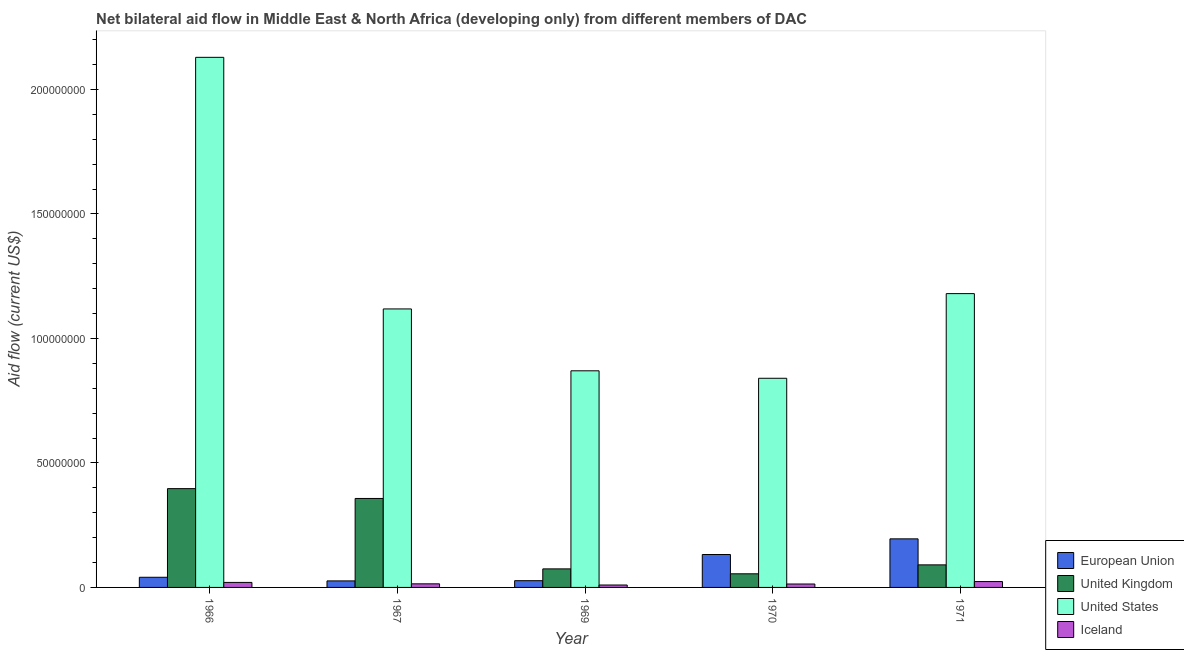How many different coloured bars are there?
Provide a short and direct response. 4. Are the number of bars per tick equal to the number of legend labels?
Keep it short and to the point. Yes. Are the number of bars on each tick of the X-axis equal?
Provide a short and direct response. Yes. How many bars are there on the 5th tick from the left?
Offer a very short reply. 4. How many bars are there on the 5th tick from the right?
Offer a very short reply. 4. What is the label of the 1st group of bars from the left?
Keep it short and to the point. 1966. What is the amount of aid given by iceland in 1969?
Offer a terse response. 9.70e+05. Across all years, what is the maximum amount of aid given by us?
Make the answer very short. 2.13e+08. Across all years, what is the minimum amount of aid given by iceland?
Offer a very short reply. 9.70e+05. In which year was the amount of aid given by us maximum?
Provide a short and direct response. 1966. In which year was the amount of aid given by iceland minimum?
Offer a very short reply. 1969. What is the total amount of aid given by iceland in the graph?
Provide a succinct answer. 8.15e+06. What is the difference between the amount of aid given by iceland in 1969 and that in 1971?
Ensure brevity in your answer.  -1.39e+06. What is the difference between the amount of aid given by uk in 1971 and the amount of aid given by eu in 1969?
Ensure brevity in your answer.  1.61e+06. What is the average amount of aid given by uk per year?
Your answer should be very brief. 1.95e+07. In how many years, is the amount of aid given by iceland greater than 100000000 US$?
Make the answer very short. 0. What is the ratio of the amount of aid given by eu in 1967 to that in 1969?
Make the answer very short. 0.97. Is the amount of aid given by us in 1966 less than that in 1970?
Give a very brief answer. No. Is the difference between the amount of aid given by us in 1969 and 1971 greater than the difference between the amount of aid given by iceland in 1969 and 1971?
Keep it short and to the point. No. What is the difference between the highest and the second highest amount of aid given by eu?
Your answer should be very brief. 6.29e+06. What is the difference between the highest and the lowest amount of aid given by eu?
Keep it short and to the point. 1.69e+07. What does the 3rd bar from the left in 1966 represents?
Offer a terse response. United States. How many bars are there?
Offer a very short reply. 20. Are the values on the major ticks of Y-axis written in scientific E-notation?
Make the answer very short. No. Does the graph contain grids?
Keep it short and to the point. No. What is the title of the graph?
Offer a very short reply. Net bilateral aid flow in Middle East & North Africa (developing only) from different members of DAC. Does "Gender equality" appear as one of the legend labels in the graph?
Keep it short and to the point. No. What is the Aid flow (current US$) of European Union in 1966?
Your response must be concise. 4.08e+06. What is the Aid flow (current US$) in United Kingdom in 1966?
Provide a succinct answer. 3.97e+07. What is the Aid flow (current US$) of United States in 1966?
Give a very brief answer. 2.13e+08. What is the Aid flow (current US$) of Iceland in 1966?
Offer a very short reply. 2.01e+06. What is the Aid flow (current US$) in European Union in 1967?
Ensure brevity in your answer.  2.62e+06. What is the Aid flow (current US$) in United Kingdom in 1967?
Keep it short and to the point. 3.57e+07. What is the Aid flow (current US$) of United States in 1967?
Provide a succinct answer. 1.12e+08. What is the Aid flow (current US$) in Iceland in 1967?
Provide a short and direct response. 1.44e+06. What is the Aid flow (current US$) of European Union in 1969?
Ensure brevity in your answer.  2.71e+06. What is the Aid flow (current US$) in United Kingdom in 1969?
Ensure brevity in your answer.  7.45e+06. What is the Aid flow (current US$) in United States in 1969?
Your answer should be compact. 8.70e+07. What is the Aid flow (current US$) in Iceland in 1969?
Offer a terse response. 9.70e+05. What is the Aid flow (current US$) in European Union in 1970?
Your answer should be compact. 1.32e+07. What is the Aid flow (current US$) in United Kingdom in 1970?
Your answer should be very brief. 5.47e+06. What is the Aid flow (current US$) in United States in 1970?
Provide a succinct answer. 8.40e+07. What is the Aid flow (current US$) of Iceland in 1970?
Ensure brevity in your answer.  1.37e+06. What is the Aid flow (current US$) of European Union in 1971?
Offer a terse response. 1.95e+07. What is the Aid flow (current US$) in United Kingdom in 1971?
Offer a very short reply. 9.06e+06. What is the Aid flow (current US$) in United States in 1971?
Give a very brief answer. 1.18e+08. What is the Aid flow (current US$) of Iceland in 1971?
Your response must be concise. 2.36e+06. Across all years, what is the maximum Aid flow (current US$) of European Union?
Provide a succinct answer. 1.95e+07. Across all years, what is the maximum Aid flow (current US$) in United Kingdom?
Your answer should be very brief. 3.97e+07. Across all years, what is the maximum Aid flow (current US$) of United States?
Offer a terse response. 2.13e+08. Across all years, what is the maximum Aid flow (current US$) of Iceland?
Your answer should be compact. 2.36e+06. Across all years, what is the minimum Aid flow (current US$) of European Union?
Offer a terse response. 2.62e+06. Across all years, what is the minimum Aid flow (current US$) in United Kingdom?
Offer a very short reply. 5.47e+06. Across all years, what is the minimum Aid flow (current US$) of United States?
Offer a very short reply. 8.40e+07. Across all years, what is the minimum Aid flow (current US$) of Iceland?
Give a very brief answer. 9.70e+05. What is the total Aid flow (current US$) in European Union in the graph?
Your answer should be compact. 4.21e+07. What is the total Aid flow (current US$) in United Kingdom in the graph?
Your response must be concise. 9.74e+07. What is the total Aid flow (current US$) in United States in the graph?
Make the answer very short. 6.14e+08. What is the total Aid flow (current US$) of Iceland in the graph?
Make the answer very short. 8.15e+06. What is the difference between the Aid flow (current US$) of European Union in 1966 and that in 1967?
Keep it short and to the point. 1.46e+06. What is the difference between the Aid flow (current US$) in United Kingdom in 1966 and that in 1967?
Keep it short and to the point. 3.95e+06. What is the difference between the Aid flow (current US$) of United States in 1966 and that in 1967?
Your answer should be compact. 1.01e+08. What is the difference between the Aid flow (current US$) in Iceland in 1966 and that in 1967?
Offer a terse response. 5.70e+05. What is the difference between the Aid flow (current US$) in European Union in 1966 and that in 1969?
Your response must be concise. 1.37e+06. What is the difference between the Aid flow (current US$) of United Kingdom in 1966 and that in 1969?
Ensure brevity in your answer.  3.22e+07. What is the difference between the Aid flow (current US$) in United States in 1966 and that in 1969?
Your answer should be compact. 1.26e+08. What is the difference between the Aid flow (current US$) in Iceland in 1966 and that in 1969?
Give a very brief answer. 1.04e+06. What is the difference between the Aid flow (current US$) of European Union in 1966 and that in 1970?
Your answer should be very brief. -9.14e+06. What is the difference between the Aid flow (current US$) in United Kingdom in 1966 and that in 1970?
Provide a short and direct response. 3.42e+07. What is the difference between the Aid flow (current US$) of United States in 1966 and that in 1970?
Provide a short and direct response. 1.29e+08. What is the difference between the Aid flow (current US$) of Iceland in 1966 and that in 1970?
Provide a succinct answer. 6.40e+05. What is the difference between the Aid flow (current US$) of European Union in 1966 and that in 1971?
Your response must be concise. -1.54e+07. What is the difference between the Aid flow (current US$) of United Kingdom in 1966 and that in 1971?
Ensure brevity in your answer.  3.06e+07. What is the difference between the Aid flow (current US$) of United States in 1966 and that in 1971?
Keep it short and to the point. 9.49e+07. What is the difference between the Aid flow (current US$) in Iceland in 1966 and that in 1971?
Provide a short and direct response. -3.50e+05. What is the difference between the Aid flow (current US$) of European Union in 1967 and that in 1969?
Ensure brevity in your answer.  -9.00e+04. What is the difference between the Aid flow (current US$) of United Kingdom in 1967 and that in 1969?
Your answer should be compact. 2.83e+07. What is the difference between the Aid flow (current US$) of United States in 1967 and that in 1969?
Provide a short and direct response. 2.48e+07. What is the difference between the Aid flow (current US$) of Iceland in 1967 and that in 1969?
Offer a very short reply. 4.70e+05. What is the difference between the Aid flow (current US$) of European Union in 1967 and that in 1970?
Your response must be concise. -1.06e+07. What is the difference between the Aid flow (current US$) in United Kingdom in 1967 and that in 1970?
Your answer should be very brief. 3.03e+07. What is the difference between the Aid flow (current US$) of United States in 1967 and that in 1970?
Keep it short and to the point. 2.78e+07. What is the difference between the Aid flow (current US$) of Iceland in 1967 and that in 1970?
Offer a very short reply. 7.00e+04. What is the difference between the Aid flow (current US$) of European Union in 1967 and that in 1971?
Your answer should be very brief. -1.69e+07. What is the difference between the Aid flow (current US$) in United Kingdom in 1967 and that in 1971?
Give a very brief answer. 2.67e+07. What is the difference between the Aid flow (current US$) of United States in 1967 and that in 1971?
Keep it short and to the point. -6.15e+06. What is the difference between the Aid flow (current US$) in Iceland in 1967 and that in 1971?
Keep it short and to the point. -9.20e+05. What is the difference between the Aid flow (current US$) in European Union in 1969 and that in 1970?
Make the answer very short. -1.05e+07. What is the difference between the Aid flow (current US$) in United Kingdom in 1969 and that in 1970?
Make the answer very short. 1.98e+06. What is the difference between the Aid flow (current US$) in Iceland in 1969 and that in 1970?
Provide a short and direct response. -4.00e+05. What is the difference between the Aid flow (current US$) of European Union in 1969 and that in 1971?
Provide a short and direct response. -1.68e+07. What is the difference between the Aid flow (current US$) of United Kingdom in 1969 and that in 1971?
Provide a succinct answer. -1.61e+06. What is the difference between the Aid flow (current US$) of United States in 1969 and that in 1971?
Offer a very short reply. -3.10e+07. What is the difference between the Aid flow (current US$) in Iceland in 1969 and that in 1971?
Offer a very short reply. -1.39e+06. What is the difference between the Aid flow (current US$) of European Union in 1970 and that in 1971?
Provide a short and direct response. -6.29e+06. What is the difference between the Aid flow (current US$) in United Kingdom in 1970 and that in 1971?
Provide a succinct answer. -3.59e+06. What is the difference between the Aid flow (current US$) in United States in 1970 and that in 1971?
Provide a succinct answer. -3.40e+07. What is the difference between the Aid flow (current US$) of Iceland in 1970 and that in 1971?
Your answer should be compact. -9.90e+05. What is the difference between the Aid flow (current US$) of European Union in 1966 and the Aid flow (current US$) of United Kingdom in 1967?
Offer a terse response. -3.16e+07. What is the difference between the Aid flow (current US$) in European Union in 1966 and the Aid flow (current US$) in United States in 1967?
Give a very brief answer. -1.08e+08. What is the difference between the Aid flow (current US$) in European Union in 1966 and the Aid flow (current US$) in Iceland in 1967?
Offer a very short reply. 2.64e+06. What is the difference between the Aid flow (current US$) in United Kingdom in 1966 and the Aid flow (current US$) in United States in 1967?
Offer a terse response. -7.22e+07. What is the difference between the Aid flow (current US$) of United Kingdom in 1966 and the Aid flow (current US$) of Iceland in 1967?
Keep it short and to the point. 3.82e+07. What is the difference between the Aid flow (current US$) of United States in 1966 and the Aid flow (current US$) of Iceland in 1967?
Keep it short and to the point. 2.11e+08. What is the difference between the Aid flow (current US$) in European Union in 1966 and the Aid flow (current US$) in United Kingdom in 1969?
Provide a short and direct response. -3.37e+06. What is the difference between the Aid flow (current US$) in European Union in 1966 and the Aid flow (current US$) in United States in 1969?
Ensure brevity in your answer.  -8.29e+07. What is the difference between the Aid flow (current US$) of European Union in 1966 and the Aid flow (current US$) of Iceland in 1969?
Keep it short and to the point. 3.11e+06. What is the difference between the Aid flow (current US$) in United Kingdom in 1966 and the Aid flow (current US$) in United States in 1969?
Provide a succinct answer. -4.73e+07. What is the difference between the Aid flow (current US$) of United Kingdom in 1966 and the Aid flow (current US$) of Iceland in 1969?
Offer a terse response. 3.87e+07. What is the difference between the Aid flow (current US$) in United States in 1966 and the Aid flow (current US$) in Iceland in 1969?
Provide a short and direct response. 2.12e+08. What is the difference between the Aid flow (current US$) in European Union in 1966 and the Aid flow (current US$) in United Kingdom in 1970?
Your response must be concise. -1.39e+06. What is the difference between the Aid flow (current US$) in European Union in 1966 and the Aid flow (current US$) in United States in 1970?
Your answer should be compact. -7.99e+07. What is the difference between the Aid flow (current US$) in European Union in 1966 and the Aid flow (current US$) in Iceland in 1970?
Give a very brief answer. 2.71e+06. What is the difference between the Aid flow (current US$) in United Kingdom in 1966 and the Aid flow (current US$) in United States in 1970?
Provide a succinct answer. -4.43e+07. What is the difference between the Aid flow (current US$) in United Kingdom in 1966 and the Aid flow (current US$) in Iceland in 1970?
Your answer should be compact. 3.83e+07. What is the difference between the Aid flow (current US$) in United States in 1966 and the Aid flow (current US$) in Iceland in 1970?
Ensure brevity in your answer.  2.12e+08. What is the difference between the Aid flow (current US$) in European Union in 1966 and the Aid flow (current US$) in United Kingdom in 1971?
Give a very brief answer. -4.98e+06. What is the difference between the Aid flow (current US$) in European Union in 1966 and the Aid flow (current US$) in United States in 1971?
Your answer should be very brief. -1.14e+08. What is the difference between the Aid flow (current US$) in European Union in 1966 and the Aid flow (current US$) in Iceland in 1971?
Offer a very short reply. 1.72e+06. What is the difference between the Aid flow (current US$) of United Kingdom in 1966 and the Aid flow (current US$) of United States in 1971?
Give a very brief answer. -7.83e+07. What is the difference between the Aid flow (current US$) in United Kingdom in 1966 and the Aid flow (current US$) in Iceland in 1971?
Make the answer very short. 3.73e+07. What is the difference between the Aid flow (current US$) of United States in 1966 and the Aid flow (current US$) of Iceland in 1971?
Your answer should be compact. 2.11e+08. What is the difference between the Aid flow (current US$) in European Union in 1967 and the Aid flow (current US$) in United Kingdom in 1969?
Ensure brevity in your answer.  -4.83e+06. What is the difference between the Aid flow (current US$) of European Union in 1967 and the Aid flow (current US$) of United States in 1969?
Ensure brevity in your answer.  -8.44e+07. What is the difference between the Aid flow (current US$) in European Union in 1967 and the Aid flow (current US$) in Iceland in 1969?
Give a very brief answer. 1.65e+06. What is the difference between the Aid flow (current US$) in United Kingdom in 1967 and the Aid flow (current US$) in United States in 1969?
Offer a terse response. -5.13e+07. What is the difference between the Aid flow (current US$) of United Kingdom in 1967 and the Aid flow (current US$) of Iceland in 1969?
Give a very brief answer. 3.48e+07. What is the difference between the Aid flow (current US$) in United States in 1967 and the Aid flow (current US$) in Iceland in 1969?
Keep it short and to the point. 1.11e+08. What is the difference between the Aid flow (current US$) of European Union in 1967 and the Aid flow (current US$) of United Kingdom in 1970?
Your answer should be very brief. -2.85e+06. What is the difference between the Aid flow (current US$) of European Union in 1967 and the Aid flow (current US$) of United States in 1970?
Offer a terse response. -8.14e+07. What is the difference between the Aid flow (current US$) in European Union in 1967 and the Aid flow (current US$) in Iceland in 1970?
Provide a short and direct response. 1.25e+06. What is the difference between the Aid flow (current US$) of United Kingdom in 1967 and the Aid flow (current US$) of United States in 1970?
Your response must be concise. -4.83e+07. What is the difference between the Aid flow (current US$) of United Kingdom in 1967 and the Aid flow (current US$) of Iceland in 1970?
Give a very brief answer. 3.44e+07. What is the difference between the Aid flow (current US$) of United States in 1967 and the Aid flow (current US$) of Iceland in 1970?
Keep it short and to the point. 1.10e+08. What is the difference between the Aid flow (current US$) of European Union in 1967 and the Aid flow (current US$) of United Kingdom in 1971?
Offer a very short reply. -6.44e+06. What is the difference between the Aid flow (current US$) of European Union in 1967 and the Aid flow (current US$) of United States in 1971?
Give a very brief answer. -1.15e+08. What is the difference between the Aid flow (current US$) of European Union in 1967 and the Aid flow (current US$) of Iceland in 1971?
Provide a succinct answer. 2.60e+05. What is the difference between the Aid flow (current US$) in United Kingdom in 1967 and the Aid flow (current US$) in United States in 1971?
Offer a very short reply. -8.23e+07. What is the difference between the Aid flow (current US$) in United Kingdom in 1967 and the Aid flow (current US$) in Iceland in 1971?
Give a very brief answer. 3.34e+07. What is the difference between the Aid flow (current US$) in United States in 1967 and the Aid flow (current US$) in Iceland in 1971?
Keep it short and to the point. 1.09e+08. What is the difference between the Aid flow (current US$) of European Union in 1969 and the Aid flow (current US$) of United Kingdom in 1970?
Offer a very short reply. -2.76e+06. What is the difference between the Aid flow (current US$) in European Union in 1969 and the Aid flow (current US$) in United States in 1970?
Your answer should be very brief. -8.13e+07. What is the difference between the Aid flow (current US$) in European Union in 1969 and the Aid flow (current US$) in Iceland in 1970?
Ensure brevity in your answer.  1.34e+06. What is the difference between the Aid flow (current US$) in United Kingdom in 1969 and the Aid flow (current US$) in United States in 1970?
Make the answer very short. -7.66e+07. What is the difference between the Aid flow (current US$) in United Kingdom in 1969 and the Aid flow (current US$) in Iceland in 1970?
Offer a terse response. 6.08e+06. What is the difference between the Aid flow (current US$) of United States in 1969 and the Aid flow (current US$) of Iceland in 1970?
Offer a terse response. 8.56e+07. What is the difference between the Aid flow (current US$) in European Union in 1969 and the Aid flow (current US$) in United Kingdom in 1971?
Provide a short and direct response. -6.35e+06. What is the difference between the Aid flow (current US$) in European Union in 1969 and the Aid flow (current US$) in United States in 1971?
Your answer should be compact. -1.15e+08. What is the difference between the Aid flow (current US$) of United Kingdom in 1969 and the Aid flow (current US$) of United States in 1971?
Give a very brief answer. -1.11e+08. What is the difference between the Aid flow (current US$) in United Kingdom in 1969 and the Aid flow (current US$) in Iceland in 1971?
Offer a very short reply. 5.09e+06. What is the difference between the Aid flow (current US$) of United States in 1969 and the Aid flow (current US$) of Iceland in 1971?
Your response must be concise. 8.46e+07. What is the difference between the Aid flow (current US$) in European Union in 1970 and the Aid flow (current US$) in United Kingdom in 1971?
Offer a very short reply. 4.16e+06. What is the difference between the Aid flow (current US$) in European Union in 1970 and the Aid flow (current US$) in United States in 1971?
Offer a very short reply. -1.05e+08. What is the difference between the Aid flow (current US$) in European Union in 1970 and the Aid flow (current US$) in Iceland in 1971?
Offer a very short reply. 1.09e+07. What is the difference between the Aid flow (current US$) in United Kingdom in 1970 and the Aid flow (current US$) in United States in 1971?
Provide a succinct answer. -1.13e+08. What is the difference between the Aid flow (current US$) in United Kingdom in 1970 and the Aid flow (current US$) in Iceland in 1971?
Ensure brevity in your answer.  3.11e+06. What is the difference between the Aid flow (current US$) of United States in 1970 and the Aid flow (current US$) of Iceland in 1971?
Your response must be concise. 8.16e+07. What is the average Aid flow (current US$) in European Union per year?
Ensure brevity in your answer.  8.43e+06. What is the average Aid flow (current US$) in United Kingdom per year?
Offer a terse response. 1.95e+07. What is the average Aid flow (current US$) of United States per year?
Make the answer very short. 1.23e+08. What is the average Aid flow (current US$) in Iceland per year?
Your answer should be compact. 1.63e+06. In the year 1966, what is the difference between the Aid flow (current US$) in European Union and Aid flow (current US$) in United Kingdom?
Ensure brevity in your answer.  -3.56e+07. In the year 1966, what is the difference between the Aid flow (current US$) of European Union and Aid flow (current US$) of United States?
Offer a very short reply. -2.09e+08. In the year 1966, what is the difference between the Aid flow (current US$) of European Union and Aid flow (current US$) of Iceland?
Provide a succinct answer. 2.07e+06. In the year 1966, what is the difference between the Aid flow (current US$) in United Kingdom and Aid flow (current US$) in United States?
Your answer should be very brief. -1.73e+08. In the year 1966, what is the difference between the Aid flow (current US$) of United Kingdom and Aid flow (current US$) of Iceland?
Your answer should be very brief. 3.77e+07. In the year 1966, what is the difference between the Aid flow (current US$) in United States and Aid flow (current US$) in Iceland?
Provide a succinct answer. 2.11e+08. In the year 1967, what is the difference between the Aid flow (current US$) in European Union and Aid flow (current US$) in United Kingdom?
Your response must be concise. -3.31e+07. In the year 1967, what is the difference between the Aid flow (current US$) of European Union and Aid flow (current US$) of United States?
Offer a terse response. -1.09e+08. In the year 1967, what is the difference between the Aid flow (current US$) in European Union and Aid flow (current US$) in Iceland?
Offer a very short reply. 1.18e+06. In the year 1967, what is the difference between the Aid flow (current US$) of United Kingdom and Aid flow (current US$) of United States?
Your answer should be very brief. -7.61e+07. In the year 1967, what is the difference between the Aid flow (current US$) in United Kingdom and Aid flow (current US$) in Iceland?
Your response must be concise. 3.43e+07. In the year 1967, what is the difference between the Aid flow (current US$) in United States and Aid flow (current US$) in Iceland?
Your answer should be very brief. 1.10e+08. In the year 1969, what is the difference between the Aid flow (current US$) of European Union and Aid flow (current US$) of United Kingdom?
Your answer should be very brief. -4.74e+06. In the year 1969, what is the difference between the Aid flow (current US$) of European Union and Aid flow (current US$) of United States?
Provide a succinct answer. -8.43e+07. In the year 1969, what is the difference between the Aid flow (current US$) of European Union and Aid flow (current US$) of Iceland?
Offer a terse response. 1.74e+06. In the year 1969, what is the difference between the Aid flow (current US$) in United Kingdom and Aid flow (current US$) in United States?
Ensure brevity in your answer.  -7.96e+07. In the year 1969, what is the difference between the Aid flow (current US$) in United Kingdom and Aid flow (current US$) in Iceland?
Provide a succinct answer. 6.48e+06. In the year 1969, what is the difference between the Aid flow (current US$) of United States and Aid flow (current US$) of Iceland?
Your answer should be very brief. 8.60e+07. In the year 1970, what is the difference between the Aid flow (current US$) in European Union and Aid flow (current US$) in United Kingdom?
Give a very brief answer. 7.75e+06. In the year 1970, what is the difference between the Aid flow (current US$) of European Union and Aid flow (current US$) of United States?
Provide a succinct answer. -7.08e+07. In the year 1970, what is the difference between the Aid flow (current US$) of European Union and Aid flow (current US$) of Iceland?
Provide a succinct answer. 1.18e+07. In the year 1970, what is the difference between the Aid flow (current US$) of United Kingdom and Aid flow (current US$) of United States?
Offer a terse response. -7.85e+07. In the year 1970, what is the difference between the Aid flow (current US$) in United Kingdom and Aid flow (current US$) in Iceland?
Provide a succinct answer. 4.10e+06. In the year 1970, what is the difference between the Aid flow (current US$) of United States and Aid flow (current US$) of Iceland?
Your response must be concise. 8.26e+07. In the year 1971, what is the difference between the Aid flow (current US$) of European Union and Aid flow (current US$) of United Kingdom?
Ensure brevity in your answer.  1.04e+07. In the year 1971, what is the difference between the Aid flow (current US$) in European Union and Aid flow (current US$) in United States?
Ensure brevity in your answer.  -9.85e+07. In the year 1971, what is the difference between the Aid flow (current US$) of European Union and Aid flow (current US$) of Iceland?
Offer a terse response. 1.72e+07. In the year 1971, what is the difference between the Aid flow (current US$) in United Kingdom and Aid flow (current US$) in United States?
Offer a very short reply. -1.09e+08. In the year 1971, what is the difference between the Aid flow (current US$) of United Kingdom and Aid flow (current US$) of Iceland?
Offer a terse response. 6.70e+06. In the year 1971, what is the difference between the Aid flow (current US$) of United States and Aid flow (current US$) of Iceland?
Provide a short and direct response. 1.16e+08. What is the ratio of the Aid flow (current US$) of European Union in 1966 to that in 1967?
Your answer should be compact. 1.56. What is the ratio of the Aid flow (current US$) in United Kingdom in 1966 to that in 1967?
Give a very brief answer. 1.11. What is the ratio of the Aid flow (current US$) of United States in 1966 to that in 1967?
Make the answer very short. 1.9. What is the ratio of the Aid flow (current US$) of Iceland in 1966 to that in 1967?
Your answer should be very brief. 1.4. What is the ratio of the Aid flow (current US$) in European Union in 1966 to that in 1969?
Your response must be concise. 1.51. What is the ratio of the Aid flow (current US$) of United Kingdom in 1966 to that in 1969?
Provide a short and direct response. 5.33. What is the ratio of the Aid flow (current US$) of United States in 1966 to that in 1969?
Your answer should be very brief. 2.45. What is the ratio of the Aid flow (current US$) in Iceland in 1966 to that in 1969?
Give a very brief answer. 2.07. What is the ratio of the Aid flow (current US$) of European Union in 1966 to that in 1970?
Your answer should be very brief. 0.31. What is the ratio of the Aid flow (current US$) of United Kingdom in 1966 to that in 1970?
Give a very brief answer. 7.25. What is the ratio of the Aid flow (current US$) in United States in 1966 to that in 1970?
Your response must be concise. 2.53. What is the ratio of the Aid flow (current US$) in Iceland in 1966 to that in 1970?
Make the answer very short. 1.47. What is the ratio of the Aid flow (current US$) in European Union in 1966 to that in 1971?
Provide a succinct answer. 0.21. What is the ratio of the Aid flow (current US$) of United Kingdom in 1966 to that in 1971?
Offer a terse response. 4.38. What is the ratio of the Aid flow (current US$) of United States in 1966 to that in 1971?
Your response must be concise. 1.8. What is the ratio of the Aid flow (current US$) in Iceland in 1966 to that in 1971?
Make the answer very short. 0.85. What is the ratio of the Aid flow (current US$) in European Union in 1967 to that in 1969?
Offer a terse response. 0.97. What is the ratio of the Aid flow (current US$) in United Kingdom in 1967 to that in 1969?
Your answer should be very brief. 4.8. What is the ratio of the Aid flow (current US$) in United States in 1967 to that in 1969?
Offer a very short reply. 1.29. What is the ratio of the Aid flow (current US$) in Iceland in 1967 to that in 1969?
Give a very brief answer. 1.48. What is the ratio of the Aid flow (current US$) in European Union in 1967 to that in 1970?
Make the answer very short. 0.2. What is the ratio of the Aid flow (current US$) in United Kingdom in 1967 to that in 1970?
Give a very brief answer. 6.53. What is the ratio of the Aid flow (current US$) of United States in 1967 to that in 1970?
Your answer should be compact. 1.33. What is the ratio of the Aid flow (current US$) of Iceland in 1967 to that in 1970?
Offer a very short reply. 1.05. What is the ratio of the Aid flow (current US$) of European Union in 1967 to that in 1971?
Your response must be concise. 0.13. What is the ratio of the Aid flow (current US$) of United Kingdom in 1967 to that in 1971?
Provide a succinct answer. 3.94. What is the ratio of the Aid flow (current US$) of United States in 1967 to that in 1971?
Your answer should be very brief. 0.95. What is the ratio of the Aid flow (current US$) of Iceland in 1967 to that in 1971?
Keep it short and to the point. 0.61. What is the ratio of the Aid flow (current US$) in European Union in 1969 to that in 1970?
Provide a short and direct response. 0.2. What is the ratio of the Aid flow (current US$) of United Kingdom in 1969 to that in 1970?
Make the answer very short. 1.36. What is the ratio of the Aid flow (current US$) of United States in 1969 to that in 1970?
Your answer should be very brief. 1.04. What is the ratio of the Aid flow (current US$) of Iceland in 1969 to that in 1970?
Make the answer very short. 0.71. What is the ratio of the Aid flow (current US$) in European Union in 1969 to that in 1971?
Ensure brevity in your answer.  0.14. What is the ratio of the Aid flow (current US$) of United Kingdom in 1969 to that in 1971?
Offer a terse response. 0.82. What is the ratio of the Aid flow (current US$) of United States in 1969 to that in 1971?
Provide a succinct answer. 0.74. What is the ratio of the Aid flow (current US$) of Iceland in 1969 to that in 1971?
Your answer should be very brief. 0.41. What is the ratio of the Aid flow (current US$) in European Union in 1970 to that in 1971?
Give a very brief answer. 0.68. What is the ratio of the Aid flow (current US$) in United Kingdom in 1970 to that in 1971?
Your answer should be compact. 0.6. What is the ratio of the Aid flow (current US$) in United States in 1970 to that in 1971?
Ensure brevity in your answer.  0.71. What is the ratio of the Aid flow (current US$) of Iceland in 1970 to that in 1971?
Provide a short and direct response. 0.58. What is the difference between the highest and the second highest Aid flow (current US$) of European Union?
Offer a terse response. 6.29e+06. What is the difference between the highest and the second highest Aid flow (current US$) in United Kingdom?
Offer a terse response. 3.95e+06. What is the difference between the highest and the second highest Aid flow (current US$) in United States?
Offer a very short reply. 9.49e+07. What is the difference between the highest and the second highest Aid flow (current US$) in Iceland?
Ensure brevity in your answer.  3.50e+05. What is the difference between the highest and the lowest Aid flow (current US$) of European Union?
Offer a very short reply. 1.69e+07. What is the difference between the highest and the lowest Aid flow (current US$) in United Kingdom?
Keep it short and to the point. 3.42e+07. What is the difference between the highest and the lowest Aid flow (current US$) of United States?
Give a very brief answer. 1.29e+08. What is the difference between the highest and the lowest Aid flow (current US$) in Iceland?
Provide a short and direct response. 1.39e+06. 